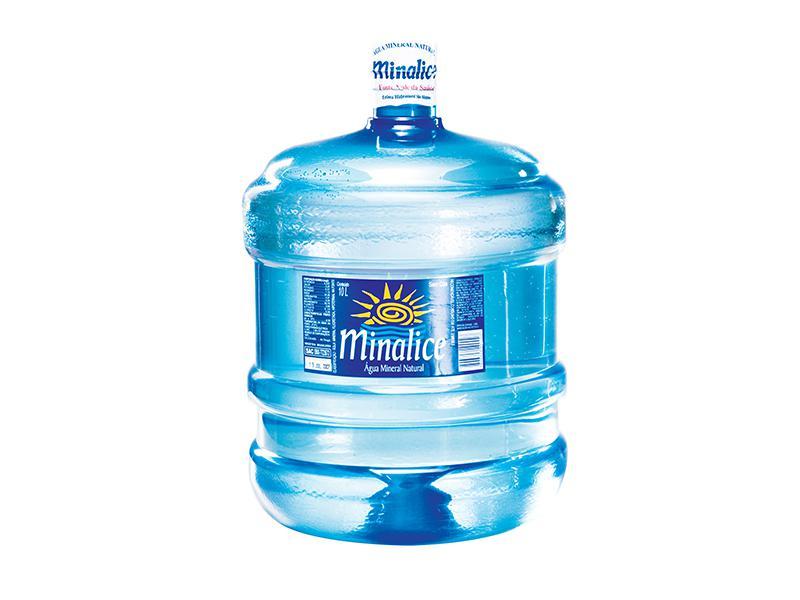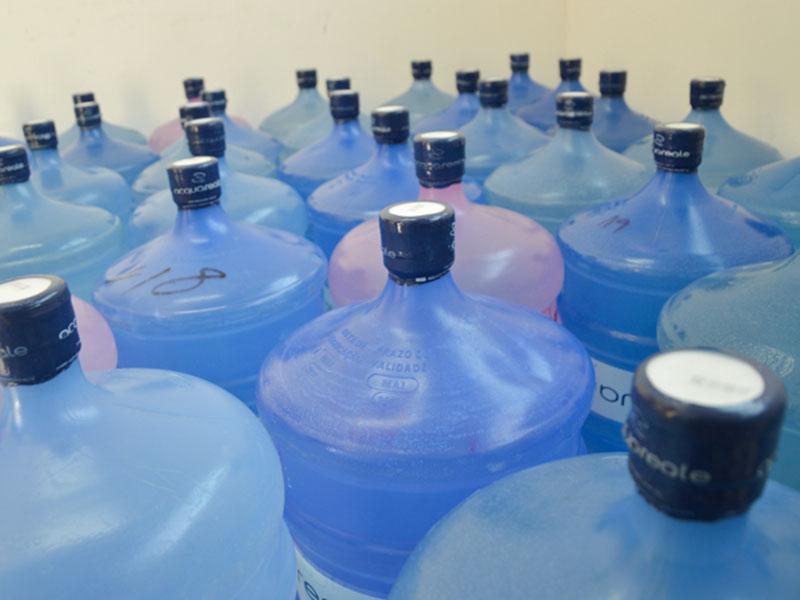The first image is the image on the left, the second image is the image on the right. For the images shown, is this caption "The left image contains no more than one upright water jug, and the right image includes only upright jugs with blue caps." true? Answer yes or no. Yes. The first image is the image on the left, the second image is the image on the right. Evaluate the accuracy of this statement regarding the images: "There are less than three bottles in the left image.". Is it true? Answer yes or no. Yes. 